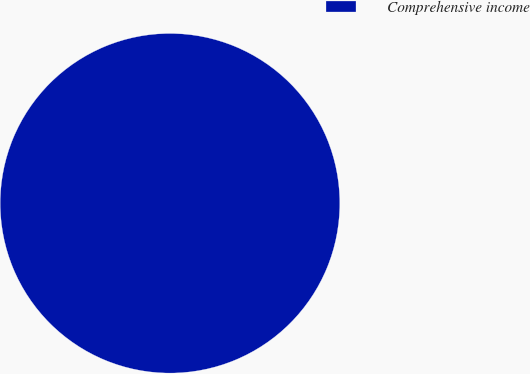<chart> <loc_0><loc_0><loc_500><loc_500><pie_chart><fcel>Comprehensive income<nl><fcel>100.0%<nl></chart> 